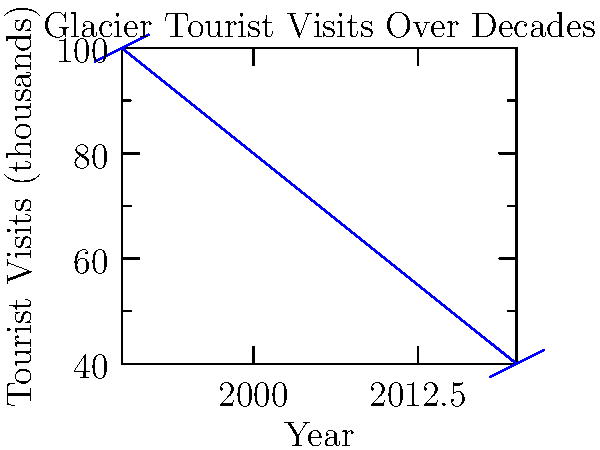Analyze the bar graph showing tourist visits to glaciers over the past decades. Calculate the average rate of decline in tourist visits per decade between 1990 and 2020. To calculate the average rate of decline in tourist visits per decade:

1. Identify the start and end points:
   1990: 100,000 visits
   2020: 40,000 visits

2. Calculate total decline:
   $100,000 - 40,000 = 60,000$ visits

3. Determine the number of decades:
   $(2020 - 1990) / 10 = 3$ decades

4. Calculate average decline per decade:
   $60,000 \div 3 = 20,000$ visits per decade

5. Express as a rate:
   $20,000$ visits per decade

This rate indicates the average number of fewer visitors each decade, highlighting the declining interest or accessibility of glacier tourism, potentially due to climate change impacts.
Answer: 20,000 visits per decade 